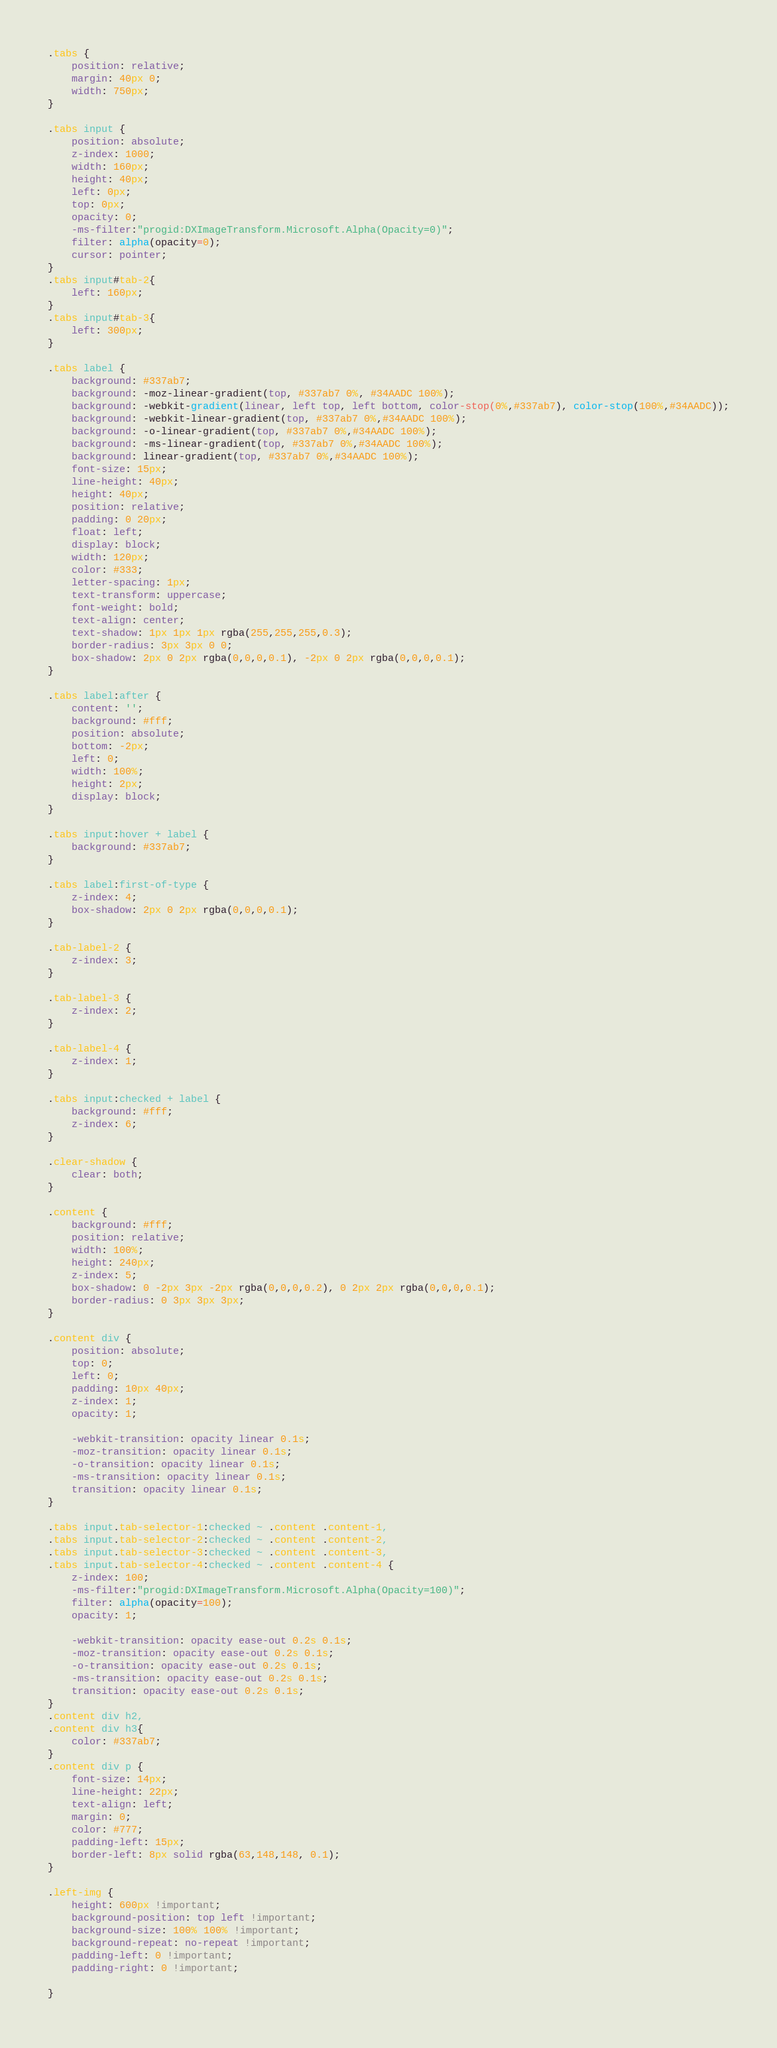Convert code to text. <code><loc_0><loc_0><loc_500><loc_500><_CSS_>.tabs {
    position: relative;
	margin: 40px 0;
	width: 750px;
}

.tabs input {
	position: absolute;
	z-index: 1000;
	width: 160px;
	height: 40px;
	left: 0px;
	top: 0px;
	opacity: 0;
    -ms-filter:"progid:DXImageTransform.Microsoft.Alpha(Opacity=0)";
    filter: alpha(opacity=0);
	cursor: pointer;
}
.tabs input#tab-2{
	left: 160px;
}
.tabs input#tab-3{
	left: 300px;
}

.tabs label {
	background: #337ab7;
	background: -moz-linear-gradient(top, #337ab7 0%, #34AADC 100%);
	background: -webkit-gradient(linear, left top, left bottom, color-stop(0%,#337ab7), color-stop(100%,#34AADC));
	background: -webkit-linear-gradient(top, #337ab7 0%,#34AADC 100%);
	background: -o-linear-gradient(top, #337ab7 0%,#34AADC 100%);
	background: -ms-linear-gradient(top, #337ab7 0%,#34AADC 100%);
	background: linear-gradient(top, #337ab7 0%,#34AADC 100%);
	font-size: 15px;
	line-height: 40px;
	height: 40px;
	position: relative;
	padding: 0 20px;
    float: left;
	display: block;
	width: 120px;
	color: #333;
	letter-spacing: 1px;
	text-transform: uppercase;
	font-weight: bold;
	text-align: center;
	text-shadow: 1px 1px 1px rgba(255,255,255,0.3);
    border-radius: 3px 3px 0 0;
    box-shadow: 2px 0 2px rgba(0,0,0,0.1), -2px 0 2px rgba(0,0,0,0.1);
}

.tabs label:after {
    content: '';
	background: #fff;
	position: absolute;
	bottom: -2px;
	left: 0;
	width: 100%;
	height: 2px;
	display: block;
}

.tabs input:hover + label {
	background: #337ab7;
}

.tabs label:first-of-type {
    z-index: 4;
    box-shadow: 2px 0 2px rgba(0,0,0,0.1);
}

.tab-label-2 {
    z-index: 3;
}

.tab-label-3 {
    z-index: 2;
}

.tab-label-4 {
    z-index: 1;
}

.tabs input:checked + label {
    background: #fff;
	z-index: 6;
}

.clear-shadow {
	clear: both;
}

.content {
    background: #fff;
	position: relative;
    width: 100%;
	height: 240px;
	z-index: 5;
    box-shadow: 0 -2px 3px -2px rgba(0,0,0,0.2), 0 2px 2px rgba(0,0,0,0.1);
    border-radius: 0 3px 3px 3px;
}

.content div {
    position: absolute;
	top: 0;
	left: 0;
	padding: 10px 40px;
	z-index: 1;
    opacity: 1;

    -webkit-transition: opacity linear 0.1s;
    -moz-transition: opacity linear 0.1s;
    -o-transition: opacity linear 0.1s;
    -ms-transition: opacity linear 0.1s;
    transition: opacity linear 0.1s;
}

.tabs input.tab-selector-1:checked ~ .content .content-1,
.tabs input.tab-selector-2:checked ~ .content .content-2,
.tabs input.tab-selector-3:checked ~ .content .content-3,
.tabs input.tab-selector-4:checked ~ .content .content-4 {
	z-index: 100;
    -ms-filter:"progid:DXImageTransform.Microsoft.Alpha(Opacity=100)";
    filter: alpha(opacity=100);
    opacity: 1;

    -webkit-transition: opacity ease-out 0.2s 0.1s;
    -moz-transition: opacity ease-out 0.2s 0.1s;
    -o-transition: opacity ease-out 0.2s 0.1s;
    -ms-transition: opacity ease-out 0.2s 0.1s;
    transition: opacity ease-out 0.2s 0.1s;
}
.content div h2,
.content div h3{
	color: #337ab7;
}
.content div p {
	font-size: 14px;
	line-height: 22px;
	text-align: left;
	margin: 0;
	color: #777;
	padding-left: 15px;
	border-left: 8px solid rgba(63,148,148, 0.1);
}

.left-img {
	height: 600px !important;
	background-position: top left !important;
	background-size: 100% 100% !important;
	background-repeat: no-repeat !important;
	padding-left: 0 !important;
	padding-right: 0 !important;

}</code> 